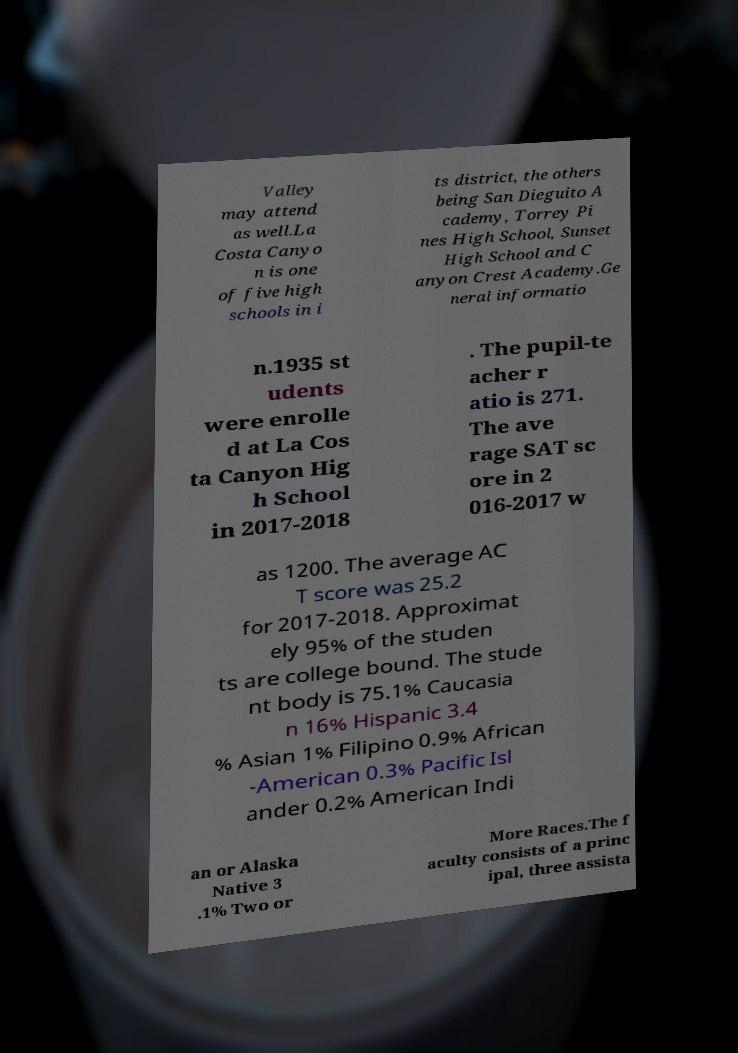Could you extract and type out the text from this image? Valley may attend as well.La Costa Canyo n is one of five high schools in i ts district, the others being San Dieguito A cademy, Torrey Pi nes High School, Sunset High School and C anyon Crest Academy.Ge neral informatio n.1935 st udents were enrolle d at La Cos ta Canyon Hig h School in 2017-2018 . The pupil-te acher r atio is 271. The ave rage SAT sc ore in 2 016-2017 w as 1200. The average AC T score was 25.2 for 2017-2018. Approximat ely 95% of the studen ts are college bound. The stude nt body is 75.1% Caucasia n 16% Hispanic 3.4 % Asian 1% Filipino 0.9% African -American 0.3% Pacific Isl ander 0.2% American Indi an or Alaska Native 3 .1% Two or More Races.The f aculty consists of a princ ipal, three assista 